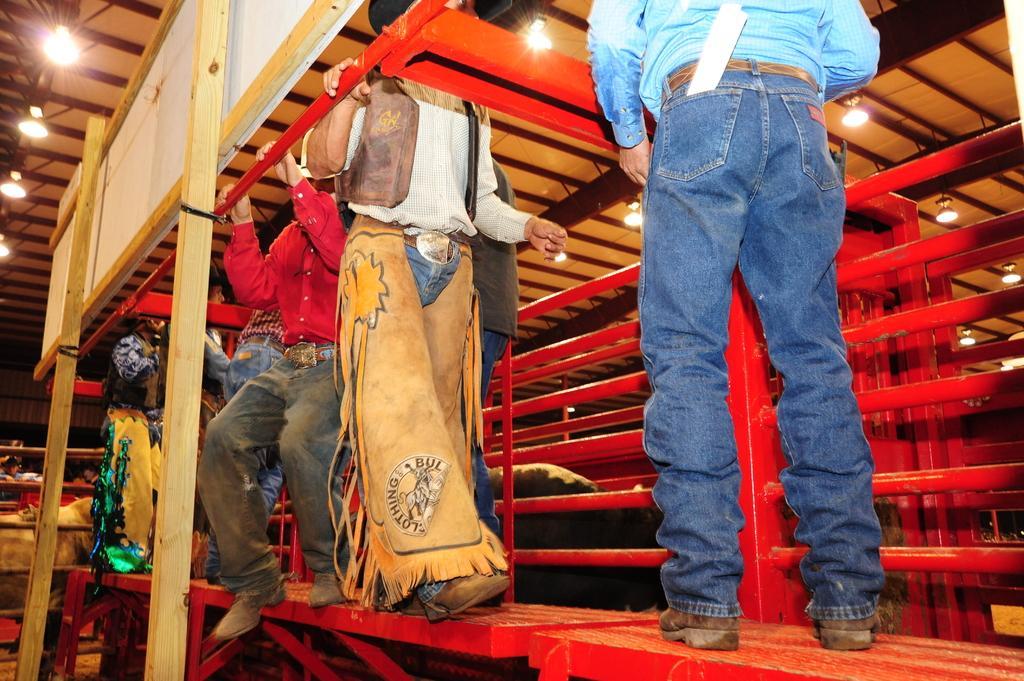Can you describe this image briefly? On the right side a man is standing, he wore trouser, shoes, a shirt. These are the iron rods in red color, in the middle a person is walking and there are persons at here. At the top there are lights. 